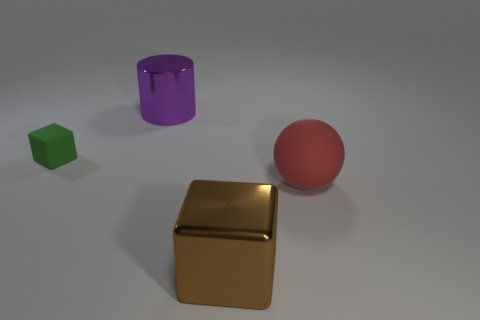Add 1 big green matte balls. How many objects exist? 5 Subtract all green cubes. How many cubes are left? 1 Subtract all spheres. How many objects are left? 3 Subtract all gray cubes. Subtract all blue cylinders. How many cubes are left? 2 Subtract all matte cubes. Subtract all large purple objects. How many objects are left? 2 Add 3 large metal things. How many large metal things are left? 5 Add 1 small yellow rubber cylinders. How many small yellow rubber cylinders exist? 1 Subtract 1 purple cylinders. How many objects are left? 3 